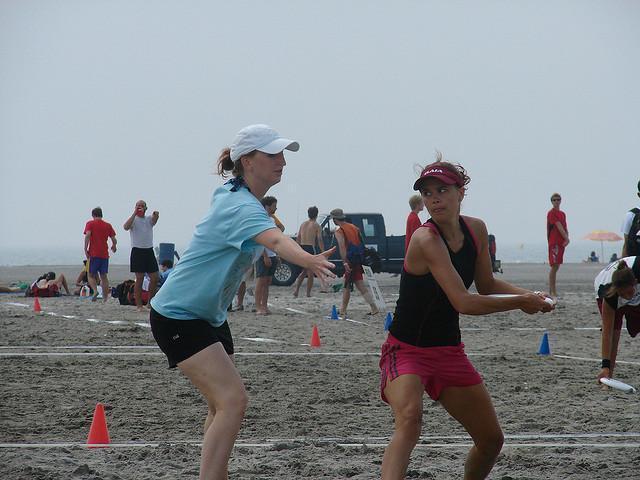How many people are there?
Give a very brief answer. 5. 